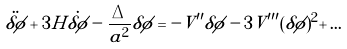<formula> <loc_0><loc_0><loc_500><loc_500>\ddot { \delta \phi } + 3 H \dot { \delta \phi } - \frac { \Delta } { a ^ { 2 } } \delta \phi = - V ^ { \prime \prime } \delta \phi - 3 V ^ { \prime \prime \prime } ( \delta \phi ) ^ { 2 } + \dots</formula> 